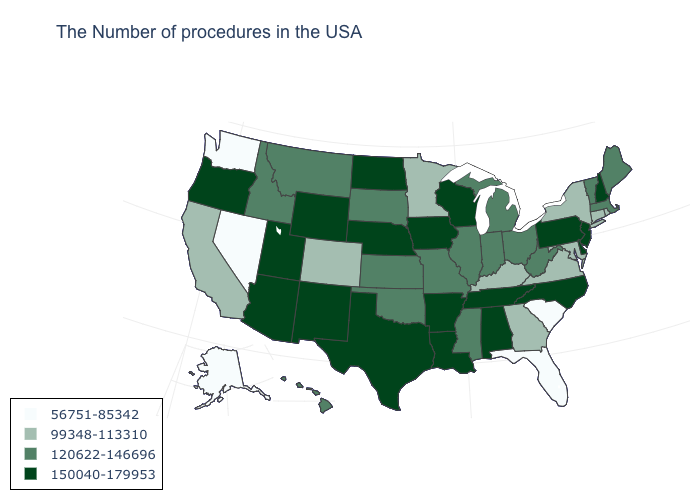Which states have the lowest value in the USA?
Answer briefly. South Carolina, Florida, Nevada, Washington, Alaska. What is the value of New York?
Be succinct. 99348-113310. Is the legend a continuous bar?
Write a very short answer. No. What is the highest value in the South ?
Answer briefly. 150040-179953. Among the states that border Oklahoma , does Colorado have the lowest value?
Concise answer only. Yes. What is the highest value in the West ?
Write a very short answer. 150040-179953. Does the map have missing data?
Answer briefly. No. Does Minnesota have a higher value than South Carolina?
Keep it brief. Yes. What is the value of Georgia?
Give a very brief answer. 99348-113310. Does Delaware have the highest value in the South?
Write a very short answer. Yes. Name the states that have a value in the range 56751-85342?
Short answer required. South Carolina, Florida, Nevada, Washington, Alaska. Name the states that have a value in the range 150040-179953?
Quick response, please. New Hampshire, New Jersey, Delaware, Pennsylvania, North Carolina, Alabama, Tennessee, Wisconsin, Louisiana, Arkansas, Iowa, Nebraska, Texas, North Dakota, Wyoming, New Mexico, Utah, Arizona, Oregon. What is the lowest value in states that border Oklahoma?
Answer briefly. 99348-113310. Does West Virginia have a lower value than North Dakota?
Keep it brief. Yes. What is the value of New Mexico?
Be succinct. 150040-179953. 